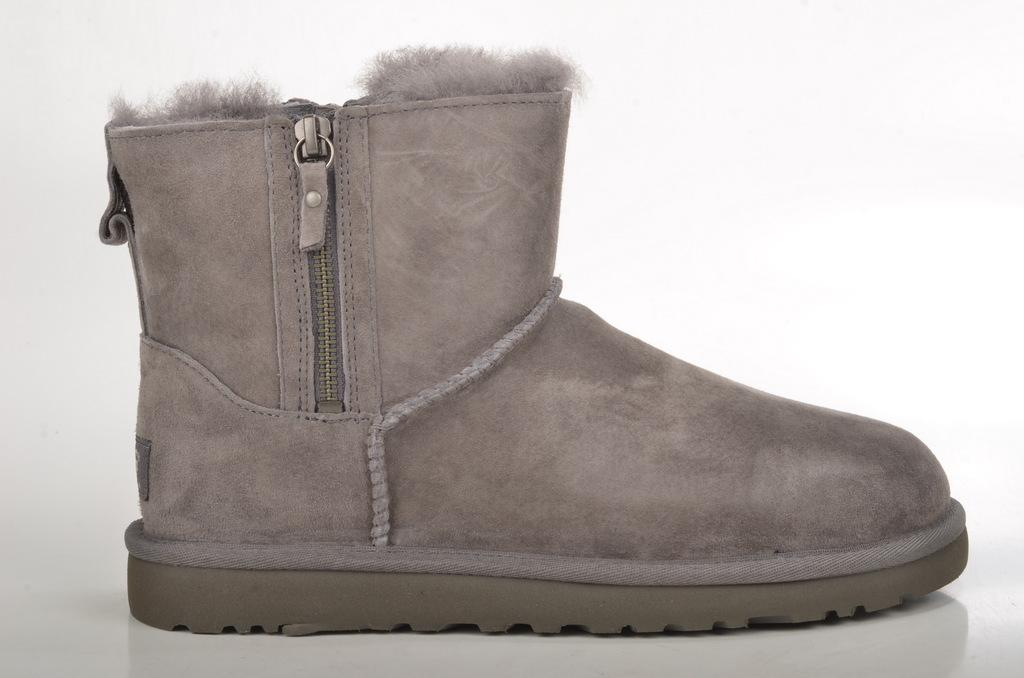What type of footwear is shown in the image? There is a mini ankle snow boot in the image. What is the snow boot placed on? The snow boot is placed on a white surface. What color is the background of the image? The background of the image is white in color. Can you see a boat navigating through a stream in the image? No, there is no boat or stream present in the image. The image only features a mini ankle snow boot placed on a white surface with a white background. 